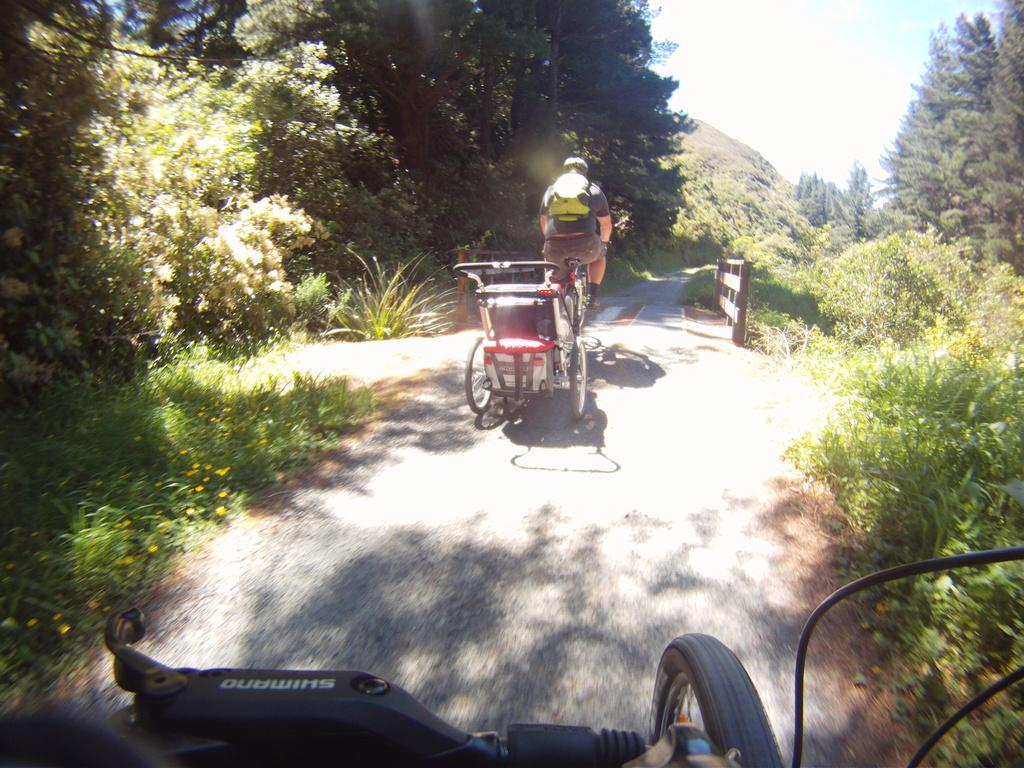Can you describe this image briefly? In this image we can see many trees and plants. There are many flowers to the plants at the left side of the image. A person is riding a vehicle in the image. There are two vehicles in the image. There is a sky in the image. There is a bridge and the fence in the image. There is a hill in the image. 